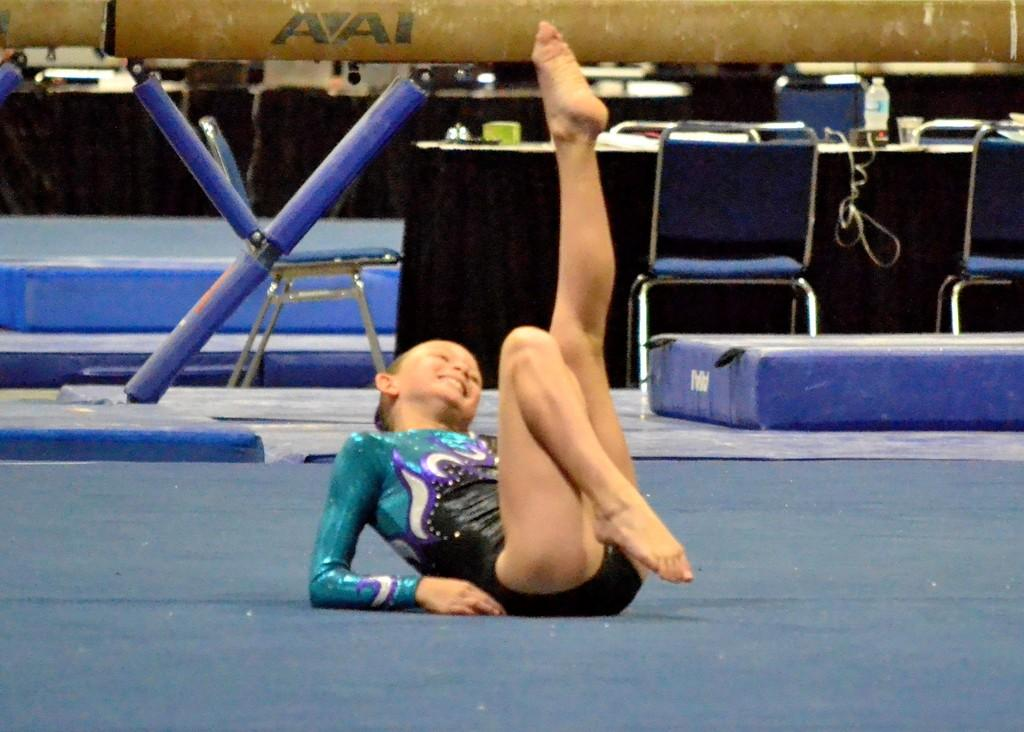Who is the main subject in the image? There is a girl in the image. Where is the girl located in the image? The girl is on the floor. What can be seen in the background of the image? There are chairs, a table, a glass, and a bottle in the background of the image. What type of kettle is being used to wash the girl's hair in the image? There is no kettle or hair washing activity present in the image. 